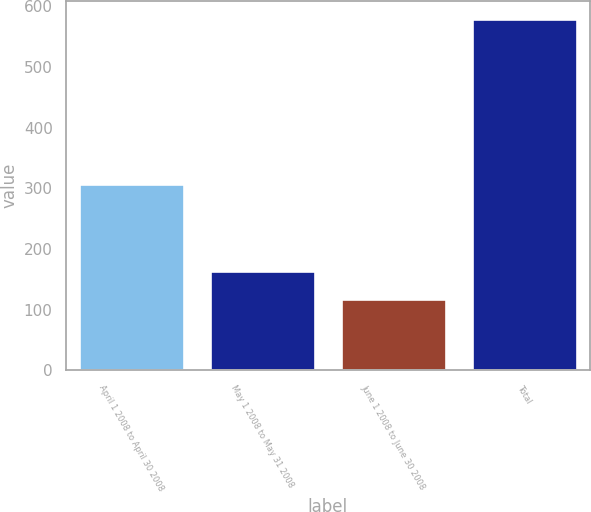<chart> <loc_0><loc_0><loc_500><loc_500><bar_chart><fcel>April 1 2008 to April 30 2008<fcel>May 1 2008 to May 31 2008<fcel>June 1 2008 to June 30 2008<fcel>Total<nl><fcel>307<fcel>164.1<fcel>118<fcel>579<nl></chart> 